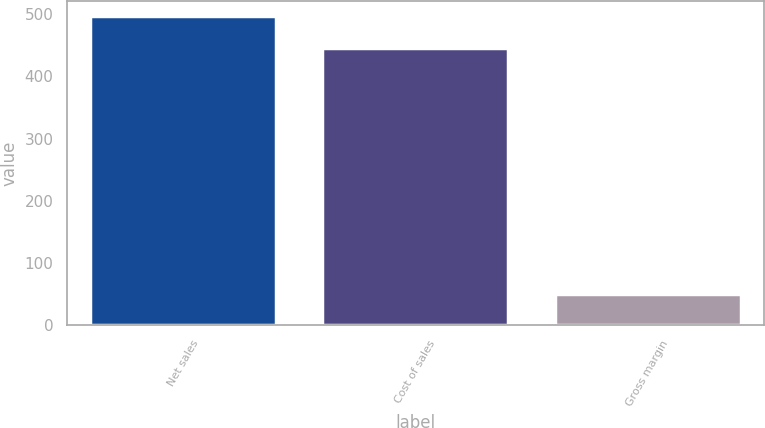Convert chart. <chart><loc_0><loc_0><loc_500><loc_500><bar_chart><fcel>Net sales<fcel>Cost of sales<fcel>Gross margin<nl><fcel>497<fcel>446<fcel>51<nl></chart> 